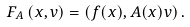Convert formula to latex. <formula><loc_0><loc_0><loc_500><loc_500>F _ { A } \left ( x , v \right ) = \left ( f ( x ) , A ( x ) v \right ) .</formula> 